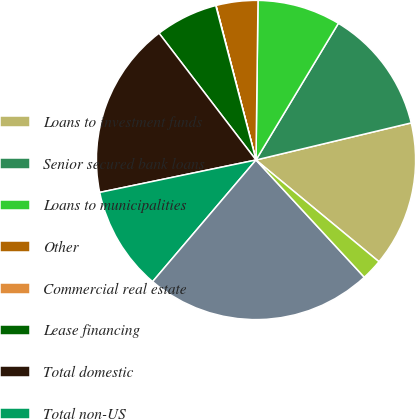<chart> <loc_0><loc_0><loc_500><loc_500><pie_chart><fcel>Loans to investment funds<fcel>Senior secured bank loans<fcel>Loans to municipalities<fcel>Other<fcel>Commercial real estate<fcel>Lease financing<fcel>Total domestic<fcel>Total non-US<fcel>Total loans and leases<fcel>Allowance for loan and lease<nl><fcel>14.73%<fcel>12.63%<fcel>8.43%<fcel>4.23%<fcel>0.03%<fcel>6.33%<fcel>17.86%<fcel>10.53%<fcel>23.08%<fcel>2.13%<nl></chart> 